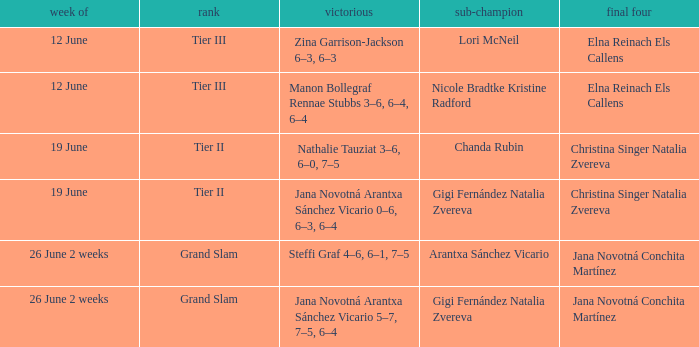When the Tier is listed as tier iii, who is the Winner? Zina Garrison-Jackson 6–3, 6–3, Manon Bollegraf Rennae Stubbs 3–6, 6–4, 6–4. 